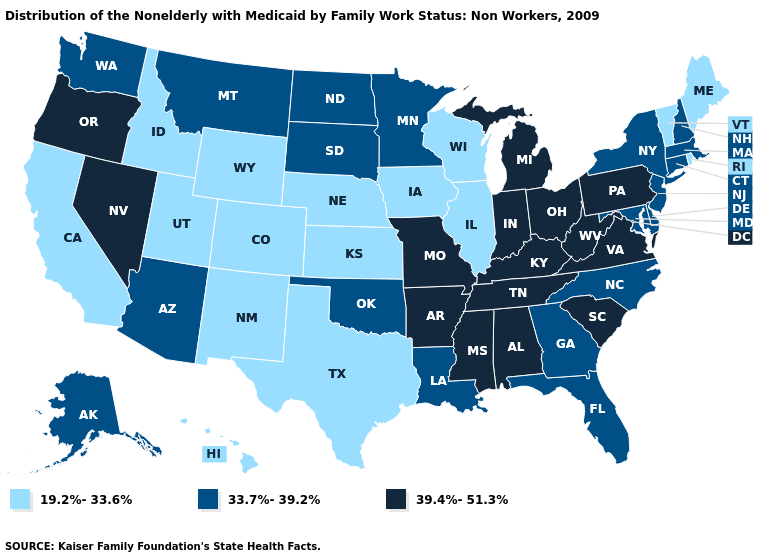Does the first symbol in the legend represent the smallest category?
Concise answer only. Yes. Name the states that have a value in the range 39.4%-51.3%?
Keep it brief. Alabama, Arkansas, Indiana, Kentucky, Michigan, Mississippi, Missouri, Nevada, Ohio, Oregon, Pennsylvania, South Carolina, Tennessee, Virginia, West Virginia. Does Nevada have the highest value in the West?
Be succinct. Yes. What is the value of Louisiana?
Short answer required. 33.7%-39.2%. Name the states that have a value in the range 39.4%-51.3%?
Quick response, please. Alabama, Arkansas, Indiana, Kentucky, Michigan, Mississippi, Missouri, Nevada, Ohio, Oregon, Pennsylvania, South Carolina, Tennessee, Virginia, West Virginia. What is the highest value in the MidWest ?
Quick response, please. 39.4%-51.3%. Does Montana have the lowest value in the USA?
Keep it brief. No. Among the states that border Idaho , which have the highest value?
Write a very short answer. Nevada, Oregon. What is the value of Alaska?
Write a very short answer. 33.7%-39.2%. What is the highest value in the Northeast ?
Quick response, please. 39.4%-51.3%. What is the lowest value in the Northeast?
Give a very brief answer. 19.2%-33.6%. Name the states that have a value in the range 33.7%-39.2%?
Quick response, please. Alaska, Arizona, Connecticut, Delaware, Florida, Georgia, Louisiana, Maryland, Massachusetts, Minnesota, Montana, New Hampshire, New Jersey, New York, North Carolina, North Dakota, Oklahoma, South Dakota, Washington. Does Hawaii have the lowest value in the West?
Answer briefly. Yes. Which states have the highest value in the USA?
Answer briefly. Alabama, Arkansas, Indiana, Kentucky, Michigan, Mississippi, Missouri, Nevada, Ohio, Oregon, Pennsylvania, South Carolina, Tennessee, Virginia, West Virginia. What is the lowest value in the USA?
Concise answer only. 19.2%-33.6%. 